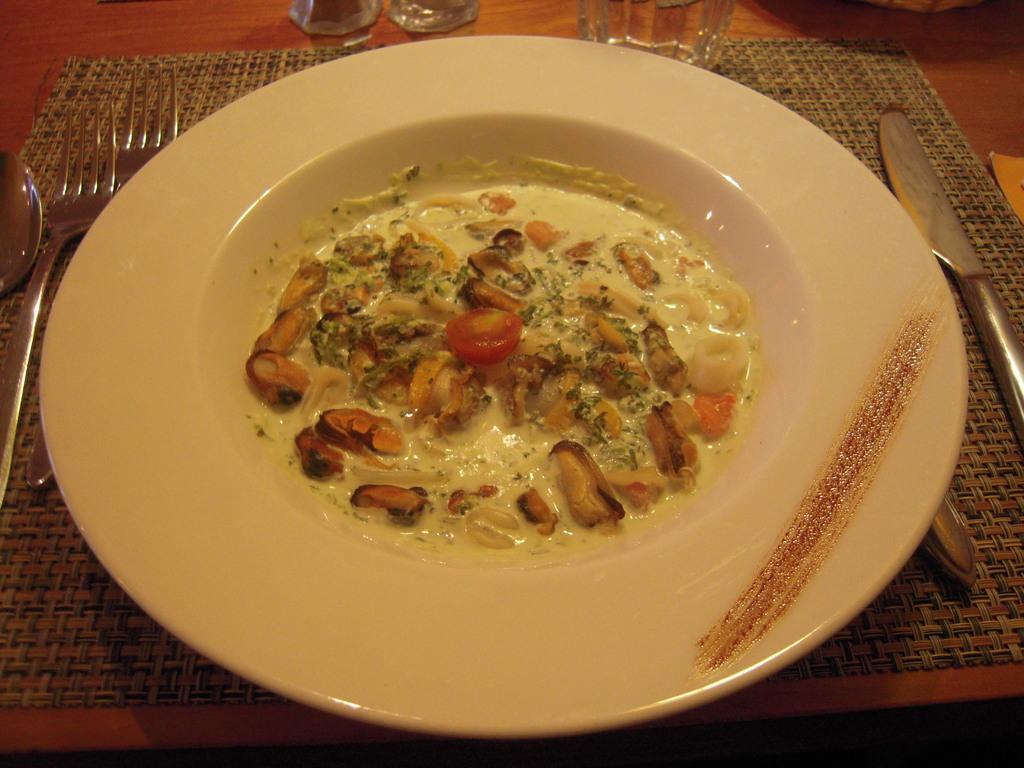Could you give a brief overview of what you see in this image? In this image I can see a brown colored table and on the table I can see few glasses, few spoons, a plate and in the plate I can see a food item which is red, cream, brown and black in color. 